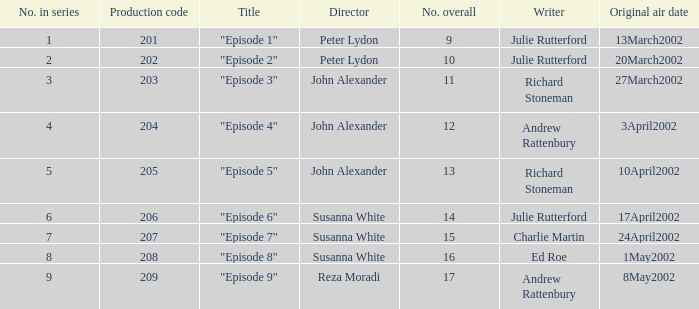When 1 is the number in series who is the director? Peter Lydon. 